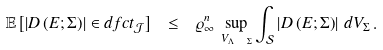Convert formula to latex. <formula><loc_0><loc_0><loc_500><loc_500>\mathbb { E } \left [ \left | D \left ( E ; \Sigma \right ) \right | \in d f c t _ { \mathcal { J } } \right ] \ \leq \ \varrho _ { \infty } ^ { n } \, \sup _ { V _ { \Lambda \ \Sigma } } \int _ { \mathcal { S } } \left | D \left ( E ; \Sigma \right ) \right | \, d V _ { \Sigma } \, .</formula> 